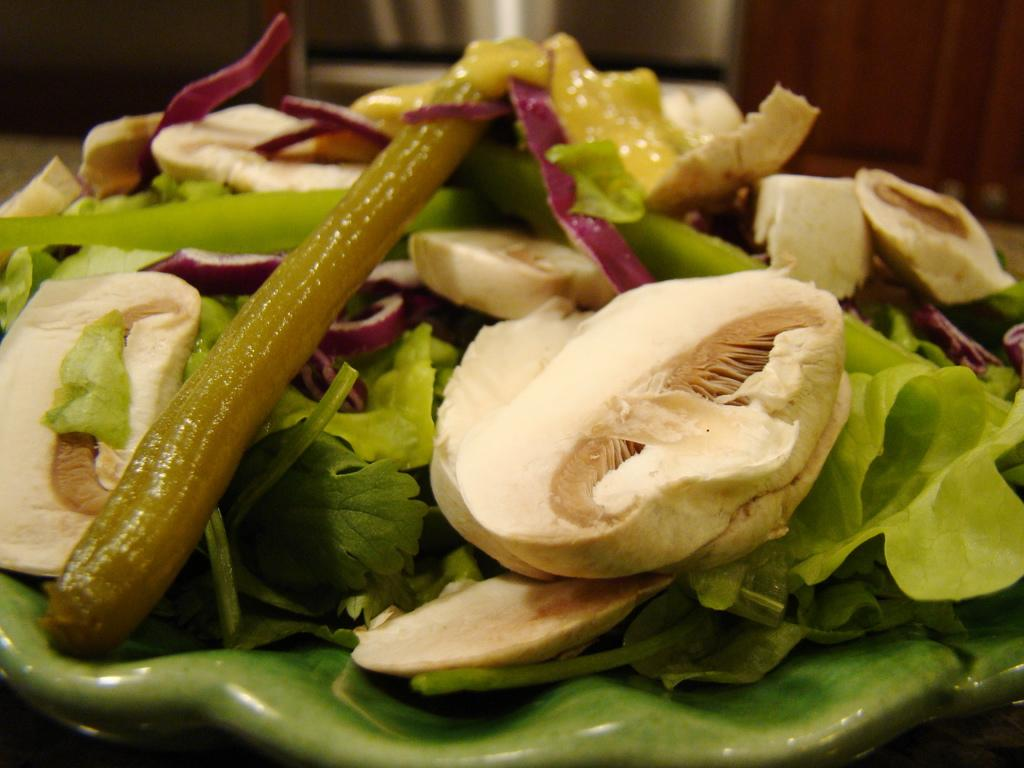What type of objects can be seen in the image? There are food items in the image. What type of plate is being used by the doctor in the food industry in the image? There is no plate, doctor, or food industry present in the image; it only contains food items. 